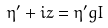Convert formula to latex. <formula><loc_0><loc_0><loc_500><loc_500>\eta ^ { \prime } + i z = \eta ^ { \prime } g I</formula> 